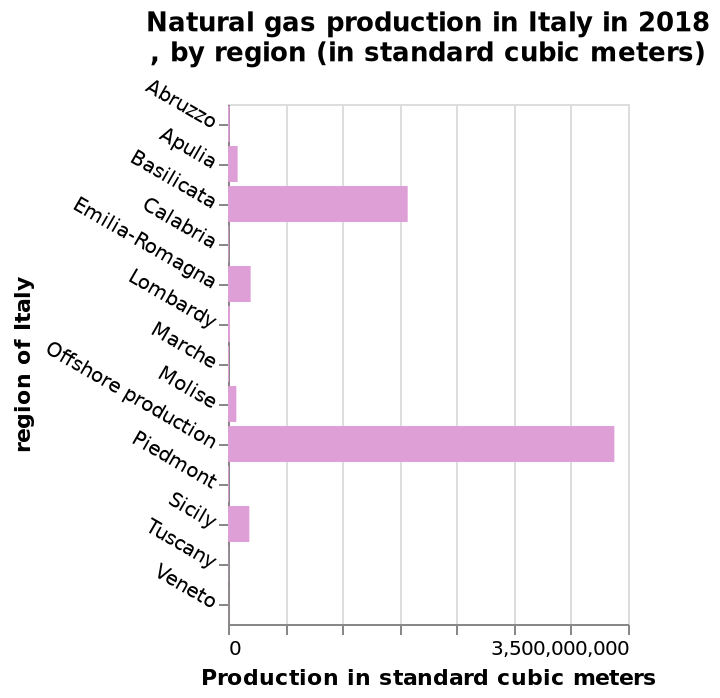<image>
What is the source of natural gas production in Italy? The overwhelming majority of natural gas production in Italy comes from off-shore sources. 